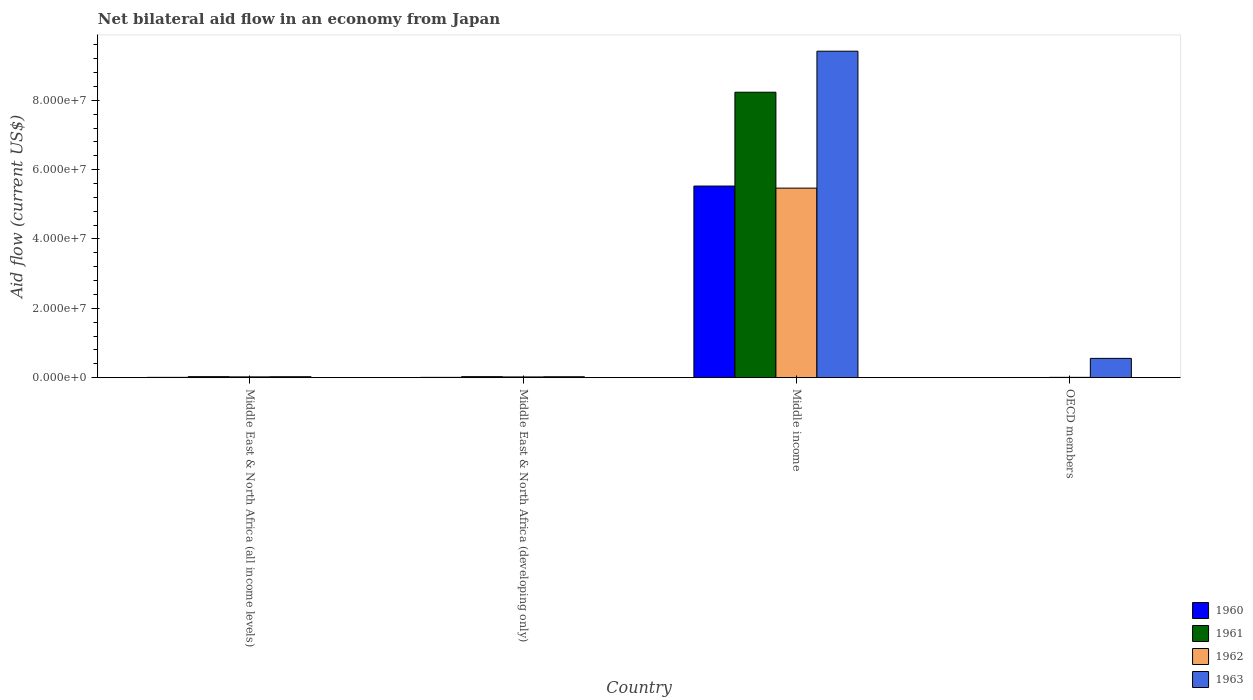How many groups of bars are there?
Make the answer very short. 4. Are the number of bars per tick equal to the number of legend labels?
Keep it short and to the point. Yes. Are the number of bars on each tick of the X-axis equal?
Keep it short and to the point. Yes. What is the label of the 2nd group of bars from the left?
Your answer should be compact. Middle East & North Africa (developing only). What is the net bilateral aid flow in 1961 in Middle East & North Africa (all income levels)?
Make the answer very short. 2.90e+05. Across all countries, what is the maximum net bilateral aid flow in 1962?
Your response must be concise. 5.47e+07. In which country was the net bilateral aid flow in 1961 maximum?
Ensure brevity in your answer.  Middle income. In which country was the net bilateral aid flow in 1960 minimum?
Keep it short and to the point. OECD members. What is the total net bilateral aid flow in 1960 in the graph?
Keep it short and to the point. 5.55e+07. What is the difference between the net bilateral aid flow in 1963 in Middle East & North Africa (all income levels) and that in OECD members?
Make the answer very short. -5.29e+06. What is the difference between the net bilateral aid flow in 1962 in Middle East & North Africa (developing only) and the net bilateral aid flow in 1961 in OECD members?
Offer a terse response. 1.60e+05. What is the average net bilateral aid flow in 1961 per country?
Offer a terse response. 2.07e+07. What is the difference between the net bilateral aid flow of/in 1961 and net bilateral aid flow of/in 1960 in OECD members?
Your response must be concise. 2.00e+04. What is the ratio of the net bilateral aid flow in 1961 in Middle income to that in OECD members?
Keep it short and to the point. 1646.4. What is the difference between the highest and the second highest net bilateral aid flow in 1960?
Offer a terse response. 5.52e+07. What is the difference between the highest and the lowest net bilateral aid flow in 1962?
Keep it short and to the point. 5.46e+07. In how many countries, is the net bilateral aid flow in 1961 greater than the average net bilateral aid flow in 1961 taken over all countries?
Make the answer very short. 1. Is the sum of the net bilateral aid flow in 1962 in Middle East & North Africa (all income levels) and OECD members greater than the maximum net bilateral aid flow in 1963 across all countries?
Give a very brief answer. No. What does the 1st bar from the left in Middle income represents?
Provide a short and direct response. 1960. What does the 4th bar from the right in Middle East & North Africa (all income levels) represents?
Give a very brief answer. 1960. How many bars are there?
Ensure brevity in your answer.  16. Are all the bars in the graph horizontal?
Offer a very short reply. No. How many countries are there in the graph?
Your response must be concise. 4. What is the difference between two consecutive major ticks on the Y-axis?
Keep it short and to the point. 2.00e+07. Does the graph contain any zero values?
Give a very brief answer. No. What is the title of the graph?
Your answer should be very brief. Net bilateral aid flow in an economy from Japan. Does "2002" appear as one of the legend labels in the graph?
Offer a very short reply. No. What is the label or title of the Y-axis?
Your answer should be compact. Aid flow (current US$). What is the Aid flow (current US$) in 1960 in Middle East & North Africa (all income levels)?
Make the answer very short. 9.00e+04. What is the Aid flow (current US$) in 1960 in Middle East & North Africa (developing only)?
Keep it short and to the point. 9.00e+04. What is the Aid flow (current US$) in 1961 in Middle East & North Africa (developing only)?
Your answer should be very brief. 2.90e+05. What is the Aid flow (current US$) in 1963 in Middle East & North Africa (developing only)?
Your answer should be very brief. 2.60e+05. What is the Aid flow (current US$) in 1960 in Middle income?
Provide a short and direct response. 5.53e+07. What is the Aid flow (current US$) in 1961 in Middle income?
Make the answer very short. 8.23e+07. What is the Aid flow (current US$) of 1962 in Middle income?
Your response must be concise. 5.47e+07. What is the Aid flow (current US$) in 1963 in Middle income?
Keep it short and to the point. 9.42e+07. What is the Aid flow (current US$) of 1960 in OECD members?
Your answer should be compact. 3.00e+04. What is the Aid flow (current US$) in 1961 in OECD members?
Your answer should be very brief. 5.00e+04. What is the Aid flow (current US$) of 1962 in OECD members?
Your response must be concise. 9.00e+04. What is the Aid flow (current US$) in 1963 in OECD members?
Provide a succinct answer. 5.56e+06. Across all countries, what is the maximum Aid flow (current US$) of 1960?
Offer a terse response. 5.53e+07. Across all countries, what is the maximum Aid flow (current US$) in 1961?
Provide a short and direct response. 8.23e+07. Across all countries, what is the maximum Aid flow (current US$) of 1962?
Your response must be concise. 5.47e+07. Across all countries, what is the maximum Aid flow (current US$) of 1963?
Ensure brevity in your answer.  9.42e+07. Across all countries, what is the minimum Aid flow (current US$) of 1960?
Your answer should be very brief. 3.00e+04. What is the total Aid flow (current US$) of 1960 in the graph?
Your answer should be very brief. 5.55e+07. What is the total Aid flow (current US$) in 1961 in the graph?
Make the answer very short. 8.30e+07. What is the total Aid flow (current US$) of 1962 in the graph?
Provide a succinct answer. 5.52e+07. What is the total Aid flow (current US$) of 1963 in the graph?
Give a very brief answer. 1.00e+08. What is the difference between the Aid flow (current US$) of 1960 in Middle East & North Africa (all income levels) and that in Middle East & North Africa (developing only)?
Make the answer very short. 0. What is the difference between the Aid flow (current US$) in 1962 in Middle East & North Africa (all income levels) and that in Middle East & North Africa (developing only)?
Your answer should be very brief. 2.00e+04. What is the difference between the Aid flow (current US$) of 1963 in Middle East & North Africa (all income levels) and that in Middle East & North Africa (developing only)?
Give a very brief answer. 10000. What is the difference between the Aid flow (current US$) of 1960 in Middle East & North Africa (all income levels) and that in Middle income?
Keep it short and to the point. -5.52e+07. What is the difference between the Aid flow (current US$) in 1961 in Middle East & North Africa (all income levels) and that in Middle income?
Offer a very short reply. -8.20e+07. What is the difference between the Aid flow (current US$) of 1962 in Middle East & North Africa (all income levels) and that in Middle income?
Ensure brevity in your answer.  -5.44e+07. What is the difference between the Aid flow (current US$) of 1963 in Middle East & North Africa (all income levels) and that in Middle income?
Ensure brevity in your answer.  -9.39e+07. What is the difference between the Aid flow (current US$) of 1961 in Middle East & North Africa (all income levels) and that in OECD members?
Your answer should be very brief. 2.40e+05. What is the difference between the Aid flow (current US$) in 1962 in Middle East & North Africa (all income levels) and that in OECD members?
Your answer should be compact. 1.40e+05. What is the difference between the Aid flow (current US$) in 1963 in Middle East & North Africa (all income levels) and that in OECD members?
Your response must be concise. -5.29e+06. What is the difference between the Aid flow (current US$) of 1960 in Middle East & North Africa (developing only) and that in Middle income?
Your response must be concise. -5.52e+07. What is the difference between the Aid flow (current US$) in 1961 in Middle East & North Africa (developing only) and that in Middle income?
Ensure brevity in your answer.  -8.20e+07. What is the difference between the Aid flow (current US$) of 1962 in Middle East & North Africa (developing only) and that in Middle income?
Make the answer very short. -5.44e+07. What is the difference between the Aid flow (current US$) of 1963 in Middle East & North Africa (developing only) and that in Middle income?
Make the answer very short. -9.39e+07. What is the difference between the Aid flow (current US$) in 1963 in Middle East & North Africa (developing only) and that in OECD members?
Provide a succinct answer. -5.30e+06. What is the difference between the Aid flow (current US$) in 1960 in Middle income and that in OECD members?
Keep it short and to the point. 5.52e+07. What is the difference between the Aid flow (current US$) in 1961 in Middle income and that in OECD members?
Keep it short and to the point. 8.23e+07. What is the difference between the Aid flow (current US$) in 1962 in Middle income and that in OECD members?
Provide a short and direct response. 5.46e+07. What is the difference between the Aid flow (current US$) in 1963 in Middle income and that in OECD members?
Your answer should be very brief. 8.86e+07. What is the difference between the Aid flow (current US$) of 1960 in Middle East & North Africa (all income levels) and the Aid flow (current US$) of 1963 in Middle East & North Africa (developing only)?
Your answer should be very brief. -1.70e+05. What is the difference between the Aid flow (current US$) of 1961 in Middle East & North Africa (all income levels) and the Aid flow (current US$) of 1963 in Middle East & North Africa (developing only)?
Your answer should be compact. 3.00e+04. What is the difference between the Aid flow (current US$) of 1962 in Middle East & North Africa (all income levels) and the Aid flow (current US$) of 1963 in Middle East & North Africa (developing only)?
Your answer should be compact. -3.00e+04. What is the difference between the Aid flow (current US$) in 1960 in Middle East & North Africa (all income levels) and the Aid flow (current US$) in 1961 in Middle income?
Your answer should be very brief. -8.22e+07. What is the difference between the Aid flow (current US$) of 1960 in Middle East & North Africa (all income levels) and the Aid flow (current US$) of 1962 in Middle income?
Your answer should be compact. -5.46e+07. What is the difference between the Aid flow (current US$) of 1960 in Middle East & North Africa (all income levels) and the Aid flow (current US$) of 1963 in Middle income?
Your response must be concise. -9.41e+07. What is the difference between the Aid flow (current US$) of 1961 in Middle East & North Africa (all income levels) and the Aid flow (current US$) of 1962 in Middle income?
Provide a succinct answer. -5.44e+07. What is the difference between the Aid flow (current US$) in 1961 in Middle East & North Africa (all income levels) and the Aid flow (current US$) in 1963 in Middle income?
Make the answer very short. -9.39e+07. What is the difference between the Aid flow (current US$) of 1962 in Middle East & North Africa (all income levels) and the Aid flow (current US$) of 1963 in Middle income?
Offer a terse response. -9.39e+07. What is the difference between the Aid flow (current US$) of 1960 in Middle East & North Africa (all income levels) and the Aid flow (current US$) of 1963 in OECD members?
Make the answer very short. -5.47e+06. What is the difference between the Aid flow (current US$) of 1961 in Middle East & North Africa (all income levels) and the Aid flow (current US$) of 1962 in OECD members?
Ensure brevity in your answer.  2.00e+05. What is the difference between the Aid flow (current US$) in 1961 in Middle East & North Africa (all income levels) and the Aid flow (current US$) in 1963 in OECD members?
Offer a terse response. -5.27e+06. What is the difference between the Aid flow (current US$) of 1962 in Middle East & North Africa (all income levels) and the Aid flow (current US$) of 1963 in OECD members?
Your answer should be very brief. -5.33e+06. What is the difference between the Aid flow (current US$) in 1960 in Middle East & North Africa (developing only) and the Aid flow (current US$) in 1961 in Middle income?
Your answer should be compact. -8.22e+07. What is the difference between the Aid flow (current US$) in 1960 in Middle East & North Africa (developing only) and the Aid flow (current US$) in 1962 in Middle income?
Your response must be concise. -5.46e+07. What is the difference between the Aid flow (current US$) in 1960 in Middle East & North Africa (developing only) and the Aid flow (current US$) in 1963 in Middle income?
Offer a terse response. -9.41e+07. What is the difference between the Aid flow (current US$) of 1961 in Middle East & North Africa (developing only) and the Aid flow (current US$) of 1962 in Middle income?
Offer a very short reply. -5.44e+07. What is the difference between the Aid flow (current US$) in 1961 in Middle East & North Africa (developing only) and the Aid flow (current US$) in 1963 in Middle income?
Your answer should be very brief. -9.39e+07. What is the difference between the Aid flow (current US$) of 1962 in Middle East & North Africa (developing only) and the Aid flow (current US$) of 1963 in Middle income?
Give a very brief answer. -9.39e+07. What is the difference between the Aid flow (current US$) in 1960 in Middle East & North Africa (developing only) and the Aid flow (current US$) in 1961 in OECD members?
Your response must be concise. 4.00e+04. What is the difference between the Aid flow (current US$) of 1960 in Middle East & North Africa (developing only) and the Aid flow (current US$) of 1962 in OECD members?
Your response must be concise. 0. What is the difference between the Aid flow (current US$) of 1960 in Middle East & North Africa (developing only) and the Aid flow (current US$) of 1963 in OECD members?
Offer a very short reply. -5.47e+06. What is the difference between the Aid flow (current US$) of 1961 in Middle East & North Africa (developing only) and the Aid flow (current US$) of 1963 in OECD members?
Provide a short and direct response. -5.27e+06. What is the difference between the Aid flow (current US$) of 1962 in Middle East & North Africa (developing only) and the Aid flow (current US$) of 1963 in OECD members?
Your response must be concise. -5.35e+06. What is the difference between the Aid flow (current US$) of 1960 in Middle income and the Aid flow (current US$) of 1961 in OECD members?
Your answer should be compact. 5.52e+07. What is the difference between the Aid flow (current US$) in 1960 in Middle income and the Aid flow (current US$) in 1962 in OECD members?
Keep it short and to the point. 5.52e+07. What is the difference between the Aid flow (current US$) of 1960 in Middle income and the Aid flow (current US$) of 1963 in OECD members?
Provide a succinct answer. 4.97e+07. What is the difference between the Aid flow (current US$) in 1961 in Middle income and the Aid flow (current US$) in 1962 in OECD members?
Give a very brief answer. 8.22e+07. What is the difference between the Aid flow (current US$) in 1961 in Middle income and the Aid flow (current US$) in 1963 in OECD members?
Ensure brevity in your answer.  7.68e+07. What is the difference between the Aid flow (current US$) in 1962 in Middle income and the Aid flow (current US$) in 1963 in OECD members?
Your answer should be compact. 4.91e+07. What is the average Aid flow (current US$) of 1960 per country?
Provide a short and direct response. 1.39e+07. What is the average Aid flow (current US$) in 1961 per country?
Your answer should be compact. 2.07e+07. What is the average Aid flow (current US$) in 1962 per country?
Your response must be concise. 1.38e+07. What is the average Aid flow (current US$) in 1963 per country?
Your response must be concise. 2.51e+07. What is the difference between the Aid flow (current US$) in 1960 and Aid flow (current US$) in 1961 in Middle East & North Africa (all income levels)?
Your response must be concise. -2.00e+05. What is the difference between the Aid flow (current US$) of 1961 and Aid flow (current US$) of 1962 in Middle East & North Africa (all income levels)?
Give a very brief answer. 6.00e+04. What is the difference between the Aid flow (current US$) of 1960 and Aid flow (current US$) of 1962 in Middle East & North Africa (developing only)?
Offer a very short reply. -1.20e+05. What is the difference between the Aid flow (current US$) in 1960 and Aid flow (current US$) in 1963 in Middle East & North Africa (developing only)?
Offer a terse response. -1.70e+05. What is the difference between the Aid flow (current US$) in 1961 and Aid flow (current US$) in 1962 in Middle East & North Africa (developing only)?
Your answer should be compact. 8.00e+04. What is the difference between the Aid flow (current US$) of 1961 and Aid flow (current US$) of 1963 in Middle East & North Africa (developing only)?
Offer a terse response. 3.00e+04. What is the difference between the Aid flow (current US$) in 1962 and Aid flow (current US$) in 1963 in Middle East & North Africa (developing only)?
Ensure brevity in your answer.  -5.00e+04. What is the difference between the Aid flow (current US$) of 1960 and Aid flow (current US$) of 1961 in Middle income?
Ensure brevity in your answer.  -2.71e+07. What is the difference between the Aid flow (current US$) in 1960 and Aid flow (current US$) in 1962 in Middle income?
Offer a very short reply. 6.00e+05. What is the difference between the Aid flow (current US$) in 1960 and Aid flow (current US$) in 1963 in Middle income?
Ensure brevity in your answer.  -3.89e+07. What is the difference between the Aid flow (current US$) in 1961 and Aid flow (current US$) in 1962 in Middle income?
Offer a terse response. 2.77e+07. What is the difference between the Aid flow (current US$) in 1961 and Aid flow (current US$) in 1963 in Middle income?
Offer a terse response. -1.18e+07. What is the difference between the Aid flow (current US$) of 1962 and Aid flow (current US$) of 1963 in Middle income?
Keep it short and to the point. -3.95e+07. What is the difference between the Aid flow (current US$) of 1960 and Aid flow (current US$) of 1962 in OECD members?
Your response must be concise. -6.00e+04. What is the difference between the Aid flow (current US$) of 1960 and Aid flow (current US$) of 1963 in OECD members?
Offer a terse response. -5.53e+06. What is the difference between the Aid flow (current US$) of 1961 and Aid flow (current US$) of 1962 in OECD members?
Your answer should be compact. -4.00e+04. What is the difference between the Aid flow (current US$) of 1961 and Aid flow (current US$) of 1963 in OECD members?
Keep it short and to the point. -5.51e+06. What is the difference between the Aid flow (current US$) of 1962 and Aid flow (current US$) of 1963 in OECD members?
Offer a very short reply. -5.47e+06. What is the ratio of the Aid flow (current US$) of 1960 in Middle East & North Africa (all income levels) to that in Middle East & North Africa (developing only)?
Your response must be concise. 1. What is the ratio of the Aid flow (current US$) in 1962 in Middle East & North Africa (all income levels) to that in Middle East & North Africa (developing only)?
Make the answer very short. 1.1. What is the ratio of the Aid flow (current US$) in 1960 in Middle East & North Africa (all income levels) to that in Middle income?
Ensure brevity in your answer.  0. What is the ratio of the Aid flow (current US$) of 1961 in Middle East & North Africa (all income levels) to that in Middle income?
Your response must be concise. 0. What is the ratio of the Aid flow (current US$) in 1962 in Middle East & North Africa (all income levels) to that in Middle income?
Keep it short and to the point. 0. What is the ratio of the Aid flow (current US$) in 1963 in Middle East & North Africa (all income levels) to that in Middle income?
Your answer should be very brief. 0. What is the ratio of the Aid flow (current US$) of 1961 in Middle East & North Africa (all income levels) to that in OECD members?
Keep it short and to the point. 5.8. What is the ratio of the Aid flow (current US$) of 1962 in Middle East & North Africa (all income levels) to that in OECD members?
Offer a terse response. 2.56. What is the ratio of the Aid flow (current US$) of 1963 in Middle East & North Africa (all income levels) to that in OECD members?
Your answer should be compact. 0.05. What is the ratio of the Aid flow (current US$) of 1960 in Middle East & North Africa (developing only) to that in Middle income?
Your response must be concise. 0. What is the ratio of the Aid flow (current US$) of 1961 in Middle East & North Africa (developing only) to that in Middle income?
Your answer should be compact. 0. What is the ratio of the Aid flow (current US$) in 1962 in Middle East & North Africa (developing only) to that in Middle income?
Offer a very short reply. 0. What is the ratio of the Aid flow (current US$) of 1963 in Middle East & North Africa (developing only) to that in Middle income?
Offer a very short reply. 0. What is the ratio of the Aid flow (current US$) in 1960 in Middle East & North Africa (developing only) to that in OECD members?
Provide a short and direct response. 3. What is the ratio of the Aid flow (current US$) of 1962 in Middle East & North Africa (developing only) to that in OECD members?
Offer a very short reply. 2.33. What is the ratio of the Aid flow (current US$) in 1963 in Middle East & North Africa (developing only) to that in OECD members?
Offer a very short reply. 0.05. What is the ratio of the Aid flow (current US$) in 1960 in Middle income to that in OECD members?
Ensure brevity in your answer.  1842. What is the ratio of the Aid flow (current US$) of 1961 in Middle income to that in OECD members?
Make the answer very short. 1646.4. What is the ratio of the Aid flow (current US$) of 1962 in Middle income to that in OECD members?
Provide a succinct answer. 607.33. What is the ratio of the Aid flow (current US$) of 1963 in Middle income to that in OECD members?
Give a very brief answer. 16.93. What is the difference between the highest and the second highest Aid flow (current US$) of 1960?
Give a very brief answer. 5.52e+07. What is the difference between the highest and the second highest Aid flow (current US$) in 1961?
Give a very brief answer. 8.20e+07. What is the difference between the highest and the second highest Aid flow (current US$) in 1962?
Your answer should be compact. 5.44e+07. What is the difference between the highest and the second highest Aid flow (current US$) in 1963?
Provide a succinct answer. 8.86e+07. What is the difference between the highest and the lowest Aid flow (current US$) in 1960?
Ensure brevity in your answer.  5.52e+07. What is the difference between the highest and the lowest Aid flow (current US$) in 1961?
Make the answer very short. 8.23e+07. What is the difference between the highest and the lowest Aid flow (current US$) of 1962?
Keep it short and to the point. 5.46e+07. What is the difference between the highest and the lowest Aid flow (current US$) in 1963?
Make the answer very short. 9.39e+07. 